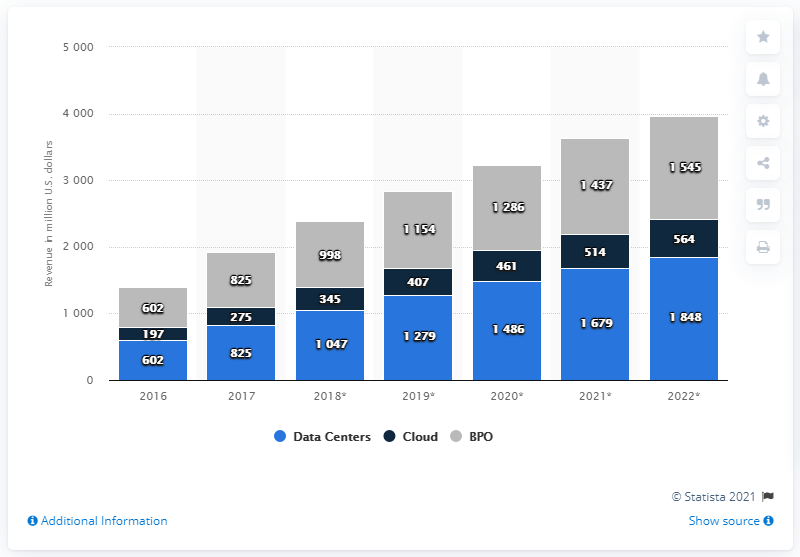Specify some key components in this picture. In 2017, the data center market in Kenya generated approximately 825 million U.S. dollars in revenue. 